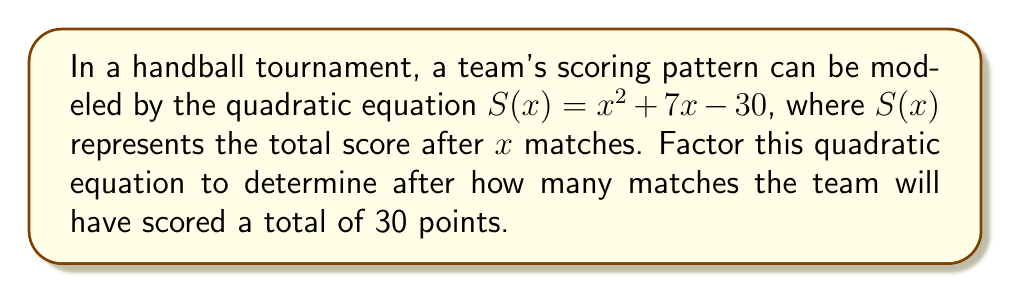Can you answer this question? To solve this problem, we need to factor the quadratic equation $S(x) = x^2 + 7x - 30$.

1) First, we recognize that this is in the form $ax^2 + bx + c$, where $a=1$, $b=7$, and $c=-30$.

2) To factor this, we need to find two numbers that multiply to give $ac = 1 \times (-30) = -30$ and add up to $b = 7$.

3) The factors of -30 are: $\pm 1, \pm 2, \pm 3, \pm 5, \pm 6, \pm 10, \pm 15, \pm 30$

4) By inspection or trial and error, we find that $10$ and $-3$ work: $10 + (-3) = 7$ and $10 \times (-3) = -30$

5) We can now rewrite the middle term:
   $x^2 + 7x - 30 = x^2 + 10x - 3x - 30$

6) Grouping these terms:
   $(x^2 + 10x) + (-3x - 30)$

7) Factoring out the common factors in each group:
   $x(x + 10) - 3(x + 10)$

8) We can now factor out $(x + 10)$:
   $(x + 10)(x - 3)$

9) Therefore, $S(x) = (x + 10)(x - 3)$

10) To find when the team will have scored 30 points, we set $S(x) = 30$:
    $(x + 10)(x - 3) = 30$

11) The team will have scored 30 points when $x = 3$ or $x = -10$. Since the number of matches can't be negative, $x = 3$ is our solution.
Answer: The quadratic equation factors to $S(x) = (x + 10)(x - 3)$. The team will have scored a total of 30 points after 3 matches. 